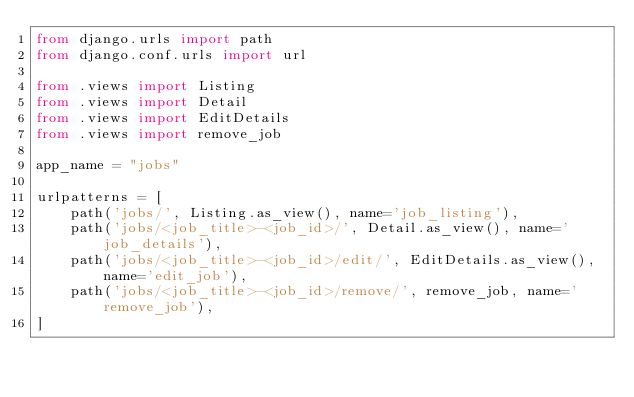Convert code to text. <code><loc_0><loc_0><loc_500><loc_500><_Python_>from django.urls import path
from django.conf.urls import url

from .views import Listing
from .views import Detail
from .views import EditDetails
from .views import remove_job

app_name = "jobs"

urlpatterns = [
    path('jobs/', Listing.as_view(), name='job_listing'),
    path('jobs/<job_title>-<job_id>/', Detail.as_view(), name='job_details'),
    path('jobs/<job_title>-<job_id>/edit/', EditDetails.as_view(), name='edit_job'),
    path('jobs/<job_title>-<job_id>/remove/', remove_job, name='remove_job'),
]
</code> 